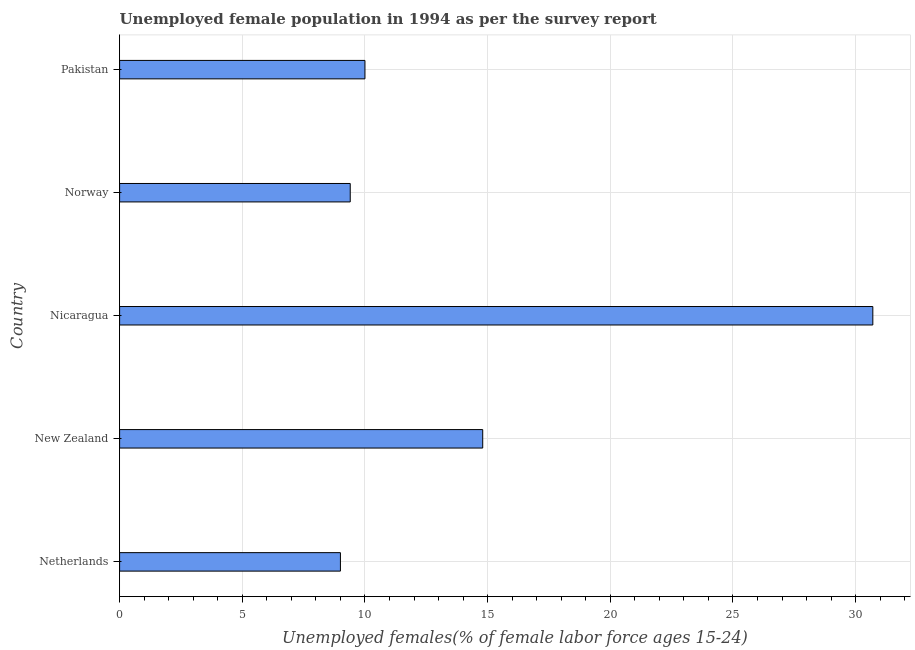Does the graph contain any zero values?
Offer a very short reply. No. Does the graph contain grids?
Offer a very short reply. Yes. What is the title of the graph?
Give a very brief answer. Unemployed female population in 1994 as per the survey report. What is the label or title of the X-axis?
Your answer should be very brief. Unemployed females(% of female labor force ages 15-24). What is the unemployed female youth in Nicaragua?
Your answer should be compact. 30.7. Across all countries, what is the maximum unemployed female youth?
Make the answer very short. 30.7. In which country was the unemployed female youth maximum?
Give a very brief answer. Nicaragua. In which country was the unemployed female youth minimum?
Give a very brief answer. Netherlands. What is the sum of the unemployed female youth?
Give a very brief answer. 73.9. What is the difference between the unemployed female youth in Netherlands and Nicaragua?
Offer a terse response. -21.7. What is the average unemployed female youth per country?
Make the answer very short. 14.78. What is the ratio of the unemployed female youth in Norway to that in Pakistan?
Offer a very short reply. 0.94. Is the unemployed female youth in Netherlands less than that in Nicaragua?
Provide a succinct answer. Yes. Is the difference between the unemployed female youth in Norway and Pakistan greater than the difference between any two countries?
Your answer should be very brief. No. What is the difference between the highest and the second highest unemployed female youth?
Your response must be concise. 15.9. Is the sum of the unemployed female youth in Norway and Pakistan greater than the maximum unemployed female youth across all countries?
Your response must be concise. No. What is the difference between the highest and the lowest unemployed female youth?
Your answer should be very brief. 21.7. In how many countries, is the unemployed female youth greater than the average unemployed female youth taken over all countries?
Offer a very short reply. 2. How many bars are there?
Keep it short and to the point. 5. Are all the bars in the graph horizontal?
Your answer should be very brief. Yes. How many countries are there in the graph?
Your response must be concise. 5. What is the difference between two consecutive major ticks on the X-axis?
Make the answer very short. 5. Are the values on the major ticks of X-axis written in scientific E-notation?
Provide a short and direct response. No. What is the Unemployed females(% of female labor force ages 15-24) in New Zealand?
Ensure brevity in your answer.  14.8. What is the Unemployed females(% of female labor force ages 15-24) of Nicaragua?
Ensure brevity in your answer.  30.7. What is the Unemployed females(% of female labor force ages 15-24) of Norway?
Ensure brevity in your answer.  9.4. What is the difference between the Unemployed females(% of female labor force ages 15-24) in Netherlands and New Zealand?
Give a very brief answer. -5.8. What is the difference between the Unemployed females(% of female labor force ages 15-24) in Netherlands and Nicaragua?
Provide a short and direct response. -21.7. What is the difference between the Unemployed females(% of female labor force ages 15-24) in Netherlands and Norway?
Make the answer very short. -0.4. What is the difference between the Unemployed females(% of female labor force ages 15-24) in Netherlands and Pakistan?
Offer a terse response. -1. What is the difference between the Unemployed females(% of female labor force ages 15-24) in New Zealand and Nicaragua?
Your response must be concise. -15.9. What is the difference between the Unemployed females(% of female labor force ages 15-24) in New Zealand and Norway?
Offer a terse response. 5.4. What is the difference between the Unemployed females(% of female labor force ages 15-24) in New Zealand and Pakistan?
Provide a short and direct response. 4.8. What is the difference between the Unemployed females(% of female labor force ages 15-24) in Nicaragua and Norway?
Your response must be concise. 21.3. What is the difference between the Unemployed females(% of female labor force ages 15-24) in Nicaragua and Pakistan?
Make the answer very short. 20.7. What is the ratio of the Unemployed females(% of female labor force ages 15-24) in Netherlands to that in New Zealand?
Your answer should be very brief. 0.61. What is the ratio of the Unemployed females(% of female labor force ages 15-24) in Netherlands to that in Nicaragua?
Your response must be concise. 0.29. What is the ratio of the Unemployed females(% of female labor force ages 15-24) in Netherlands to that in Norway?
Give a very brief answer. 0.96. What is the ratio of the Unemployed females(% of female labor force ages 15-24) in Netherlands to that in Pakistan?
Give a very brief answer. 0.9. What is the ratio of the Unemployed females(% of female labor force ages 15-24) in New Zealand to that in Nicaragua?
Your answer should be compact. 0.48. What is the ratio of the Unemployed females(% of female labor force ages 15-24) in New Zealand to that in Norway?
Give a very brief answer. 1.57. What is the ratio of the Unemployed females(% of female labor force ages 15-24) in New Zealand to that in Pakistan?
Offer a very short reply. 1.48. What is the ratio of the Unemployed females(% of female labor force ages 15-24) in Nicaragua to that in Norway?
Offer a very short reply. 3.27. What is the ratio of the Unemployed females(% of female labor force ages 15-24) in Nicaragua to that in Pakistan?
Provide a succinct answer. 3.07. What is the ratio of the Unemployed females(% of female labor force ages 15-24) in Norway to that in Pakistan?
Your answer should be very brief. 0.94. 